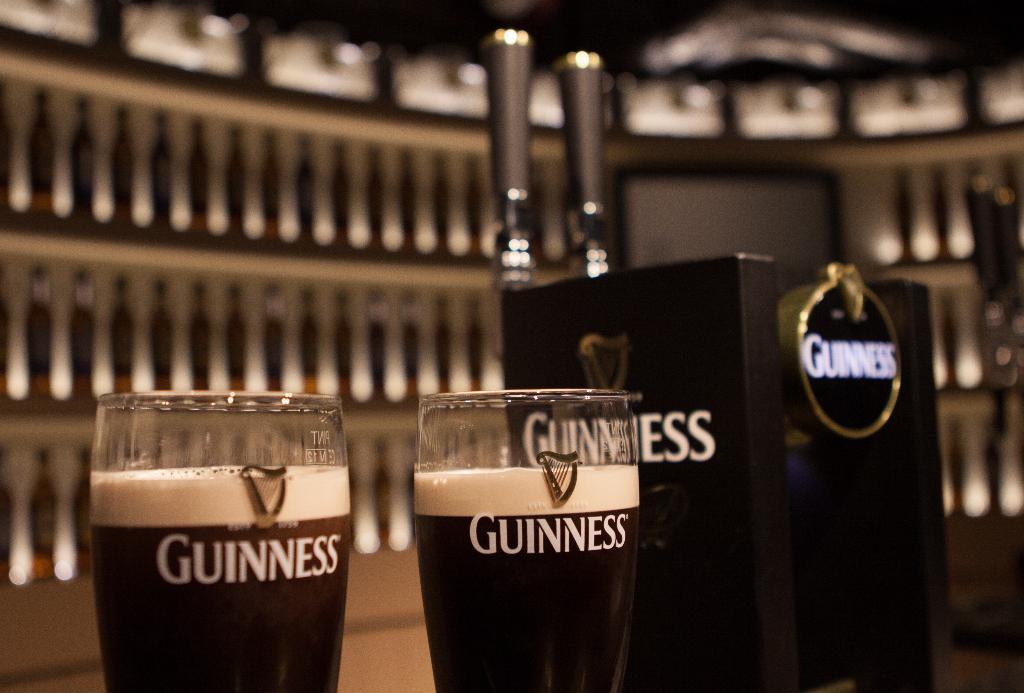Which brand of beverage is this?
Provide a short and direct response. Guinness. 